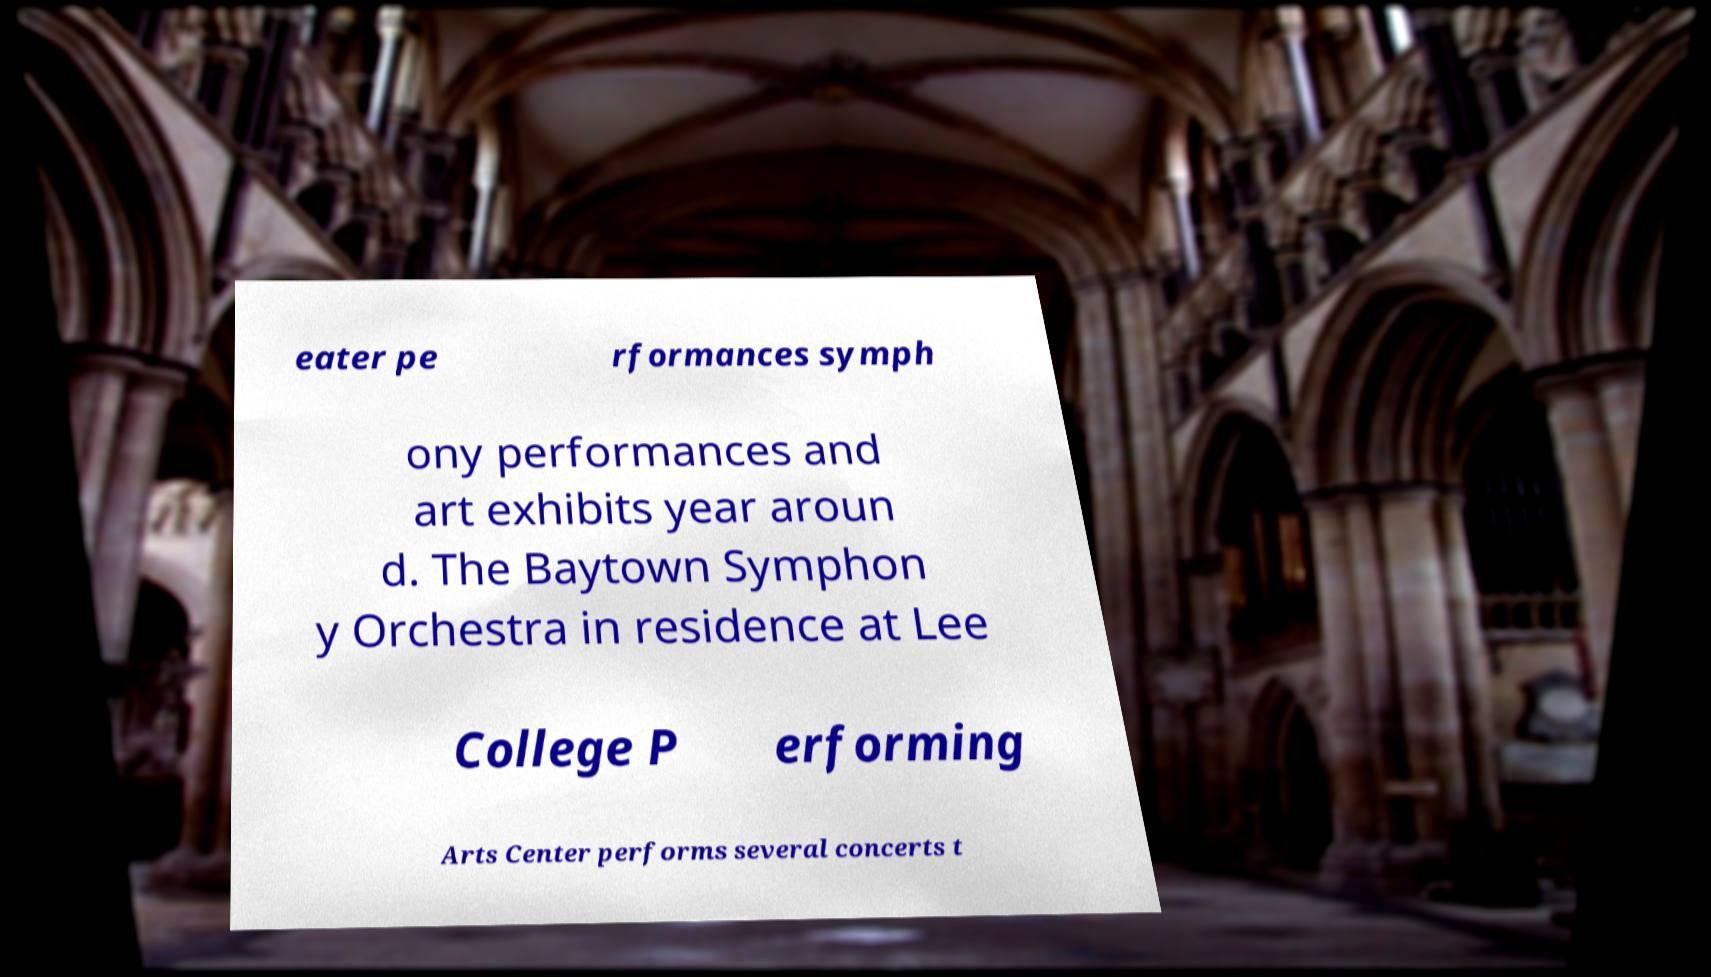Could you assist in decoding the text presented in this image and type it out clearly? eater pe rformances symph ony performances and art exhibits year aroun d. The Baytown Symphon y Orchestra in residence at Lee College P erforming Arts Center performs several concerts t 